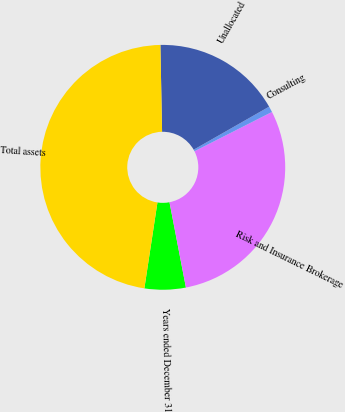<chart> <loc_0><loc_0><loc_500><loc_500><pie_chart><fcel>Years ended December 31<fcel>Risk and Insurance Brokerage<fcel>Consulting<fcel>Unallocated<fcel>Total assets<nl><fcel>5.43%<fcel>29.44%<fcel>0.78%<fcel>17.06%<fcel>47.28%<nl></chart> 